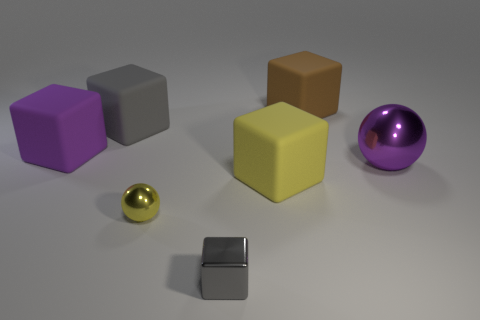Subtract all brown cylinders. How many gray blocks are left? 2 Subtract all gray blocks. How many blocks are left? 3 Subtract all gray cubes. How many cubes are left? 3 Add 3 tiny yellow matte cubes. How many objects exist? 10 Subtract all blocks. How many objects are left? 2 Subtract all purple blocks. Subtract all cyan spheres. How many blocks are left? 4 Add 3 tiny spheres. How many tiny spheres exist? 4 Subtract 1 purple balls. How many objects are left? 6 Subtract all rubber blocks. Subtract all big brown objects. How many objects are left? 2 Add 5 big yellow rubber objects. How many big yellow rubber objects are left? 6 